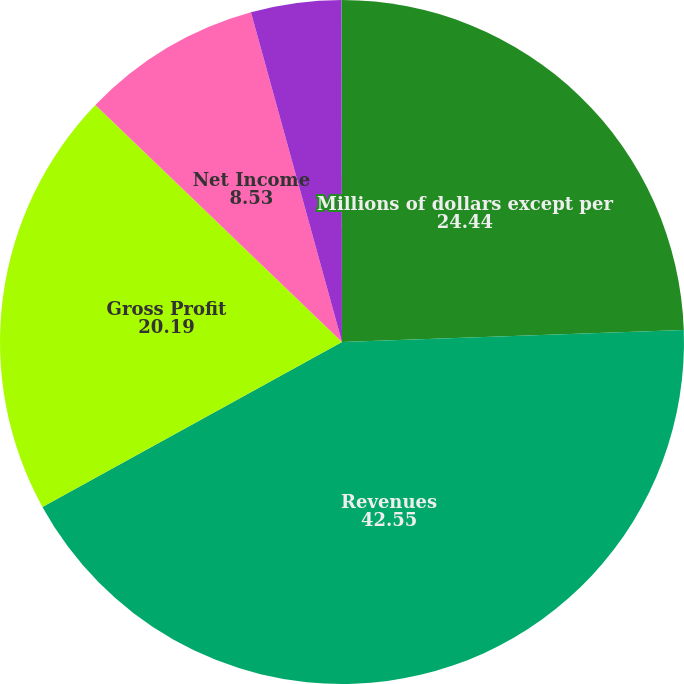Convert chart. <chart><loc_0><loc_0><loc_500><loc_500><pie_chart><fcel>Millions of dollars except per<fcel>Revenues<fcel>Gross Profit<fcel>Net Income<fcel>Basic<fcel>Diluted<nl><fcel>24.44%<fcel>42.55%<fcel>20.19%<fcel>8.53%<fcel>4.27%<fcel>0.02%<nl></chart> 